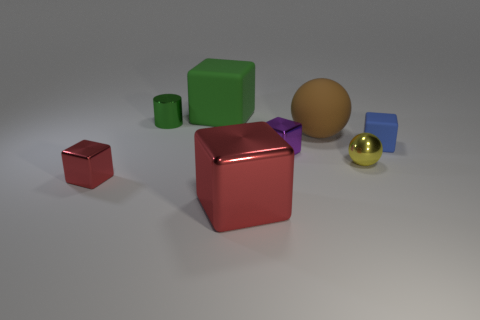Subtract 1 cubes. How many cubes are left? 4 Add 1 large purple shiny blocks. How many objects exist? 9 Subtract all cylinders. How many objects are left? 7 Subtract 0 green balls. How many objects are left? 8 Subtract all tiny blue metal spheres. Subtract all big rubber cubes. How many objects are left? 7 Add 3 blue things. How many blue things are left? 4 Add 1 small purple blocks. How many small purple blocks exist? 2 